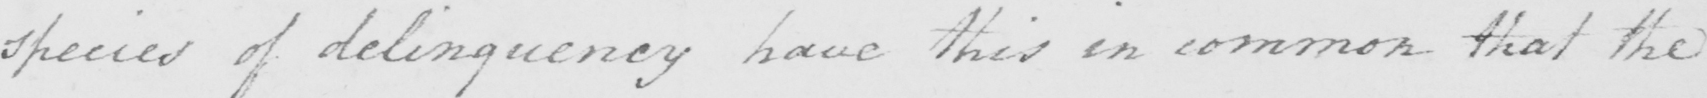What does this handwritten line say? species of delinquency have this in common that the 